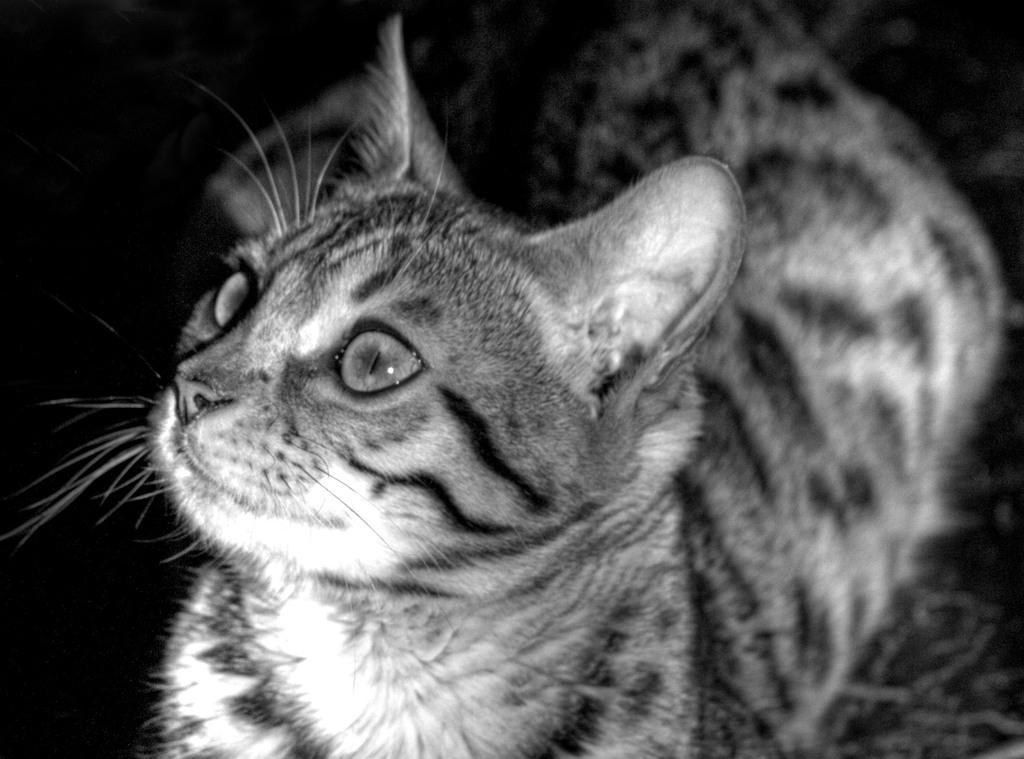Could you give a brief overview of what you see in this image? In this image I can see in the middle there is a cat. 